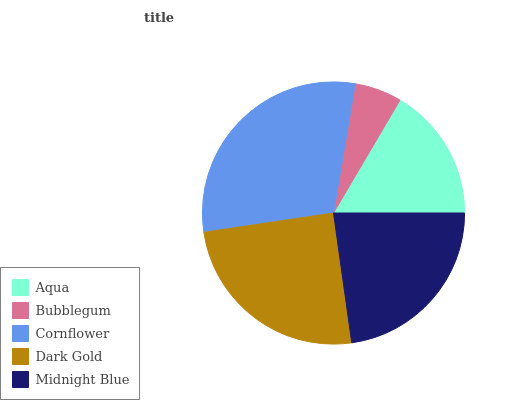Is Bubblegum the minimum?
Answer yes or no. Yes. Is Cornflower the maximum?
Answer yes or no. Yes. Is Cornflower the minimum?
Answer yes or no. No. Is Bubblegum the maximum?
Answer yes or no. No. Is Cornflower greater than Bubblegum?
Answer yes or no. Yes. Is Bubblegum less than Cornflower?
Answer yes or no. Yes. Is Bubblegum greater than Cornflower?
Answer yes or no. No. Is Cornflower less than Bubblegum?
Answer yes or no. No. Is Midnight Blue the high median?
Answer yes or no. Yes. Is Midnight Blue the low median?
Answer yes or no. Yes. Is Bubblegum the high median?
Answer yes or no. No. Is Aqua the low median?
Answer yes or no. No. 